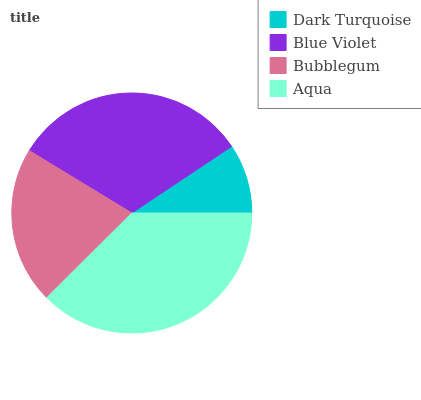Is Dark Turquoise the minimum?
Answer yes or no. Yes. Is Aqua the maximum?
Answer yes or no. Yes. Is Blue Violet the minimum?
Answer yes or no. No. Is Blue Violet the maximum?
Answer yes or no. No. Is Blue Violet greater than Dark Turquoise?
Answer yes or no. Yes. Is Dark Turquoise less than Blue Violet?
Answer yes or no. Yes. Is Dark Turquoise greater than Blue Violet?
Answer yes or no. No. Is Blue Violet less than Dark Turquoise?
Answer yes or no. No. Is Blue Violet the high median?
Answer yes or no. Yes. Is Bubblegum the low median?
Answer yes or no. Yes. Is Bubblegum the high median?
Answer yes or no. No. Is Dark Turquoise the low median?
Answer yes or no. No. 